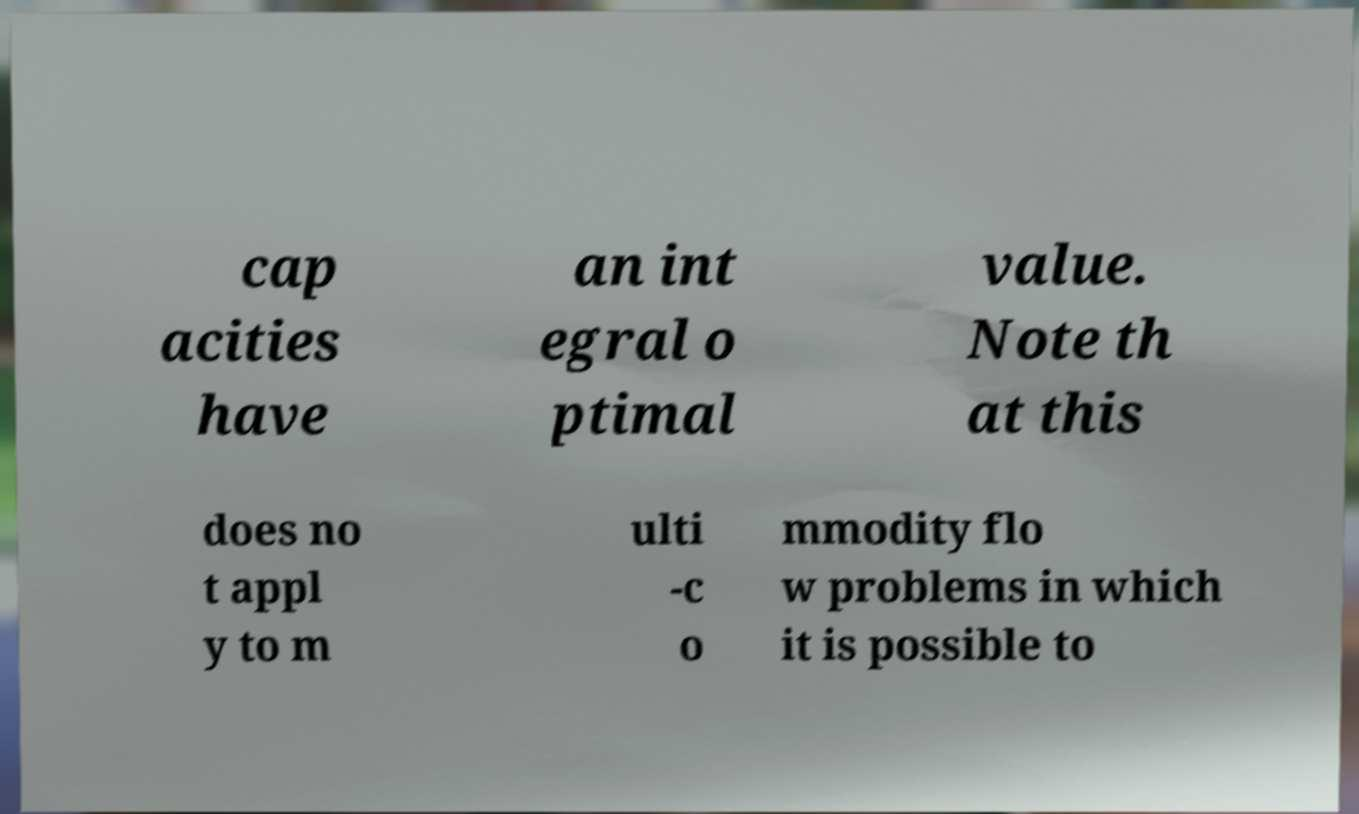Could you extract and type out the text from this image? cap acities have an int egral o ptimal value. Note th at this does no t appl y to m ulti -c o mmodity flo w problems in which it is possible to 